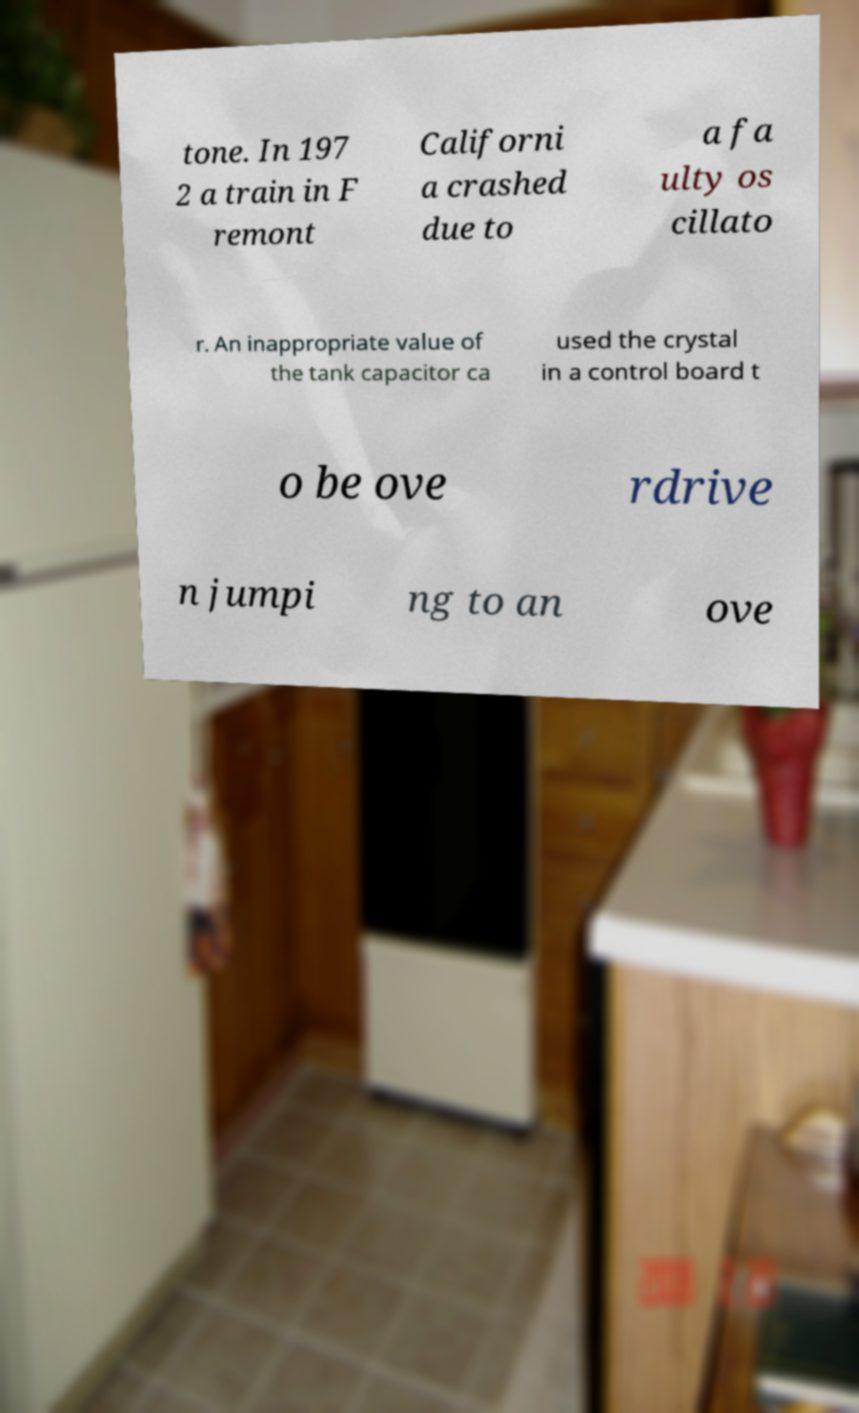Please identify and transcribe the text found in this image. tone. In 197 2 a train in F remont Californi a crashed due to a fa ulty os cillato r. An inappropriate value of the tank capacitor ca used the crystal in a control board t o be ove rdrive n jumpi ng to an ove 